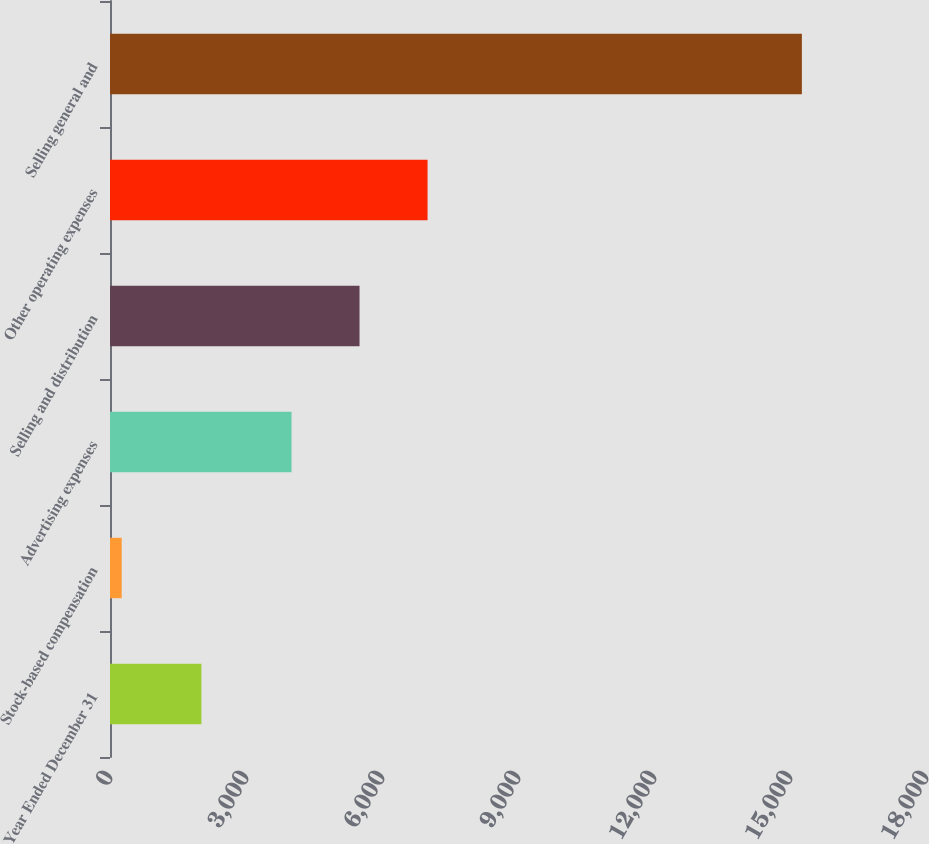Convert chart to OTSL. <chart><loc_0><loc_0><loc_500><loc_500><bar_chart><fcel>Year Ended December 31<fcel>Stock-based compensation<fcel>Advertising expenses<fcel>Selling and distribution<fcel>Other operating expenses<fcel>Selling general and<nl><fcel>2016<fcel>258<fcel>4004<fcel>5504.4<fcel>7004.8<fcel>15262<nl></chart> 